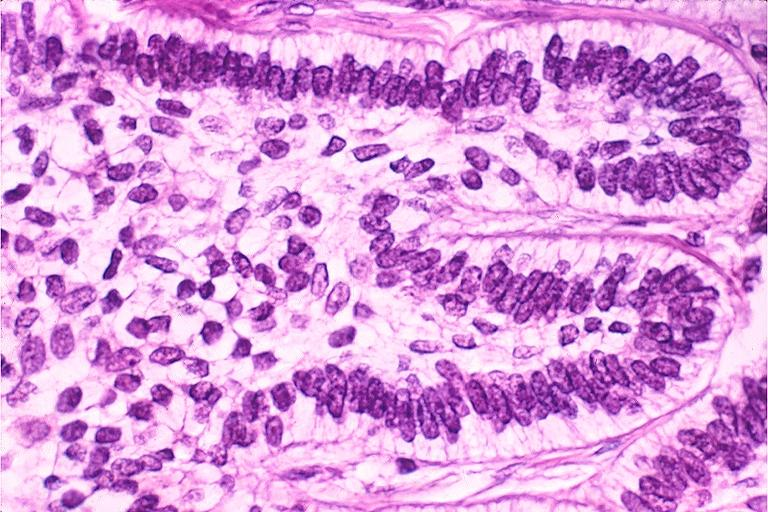where is this?
Answer the question using a single word or phrase. Oral 